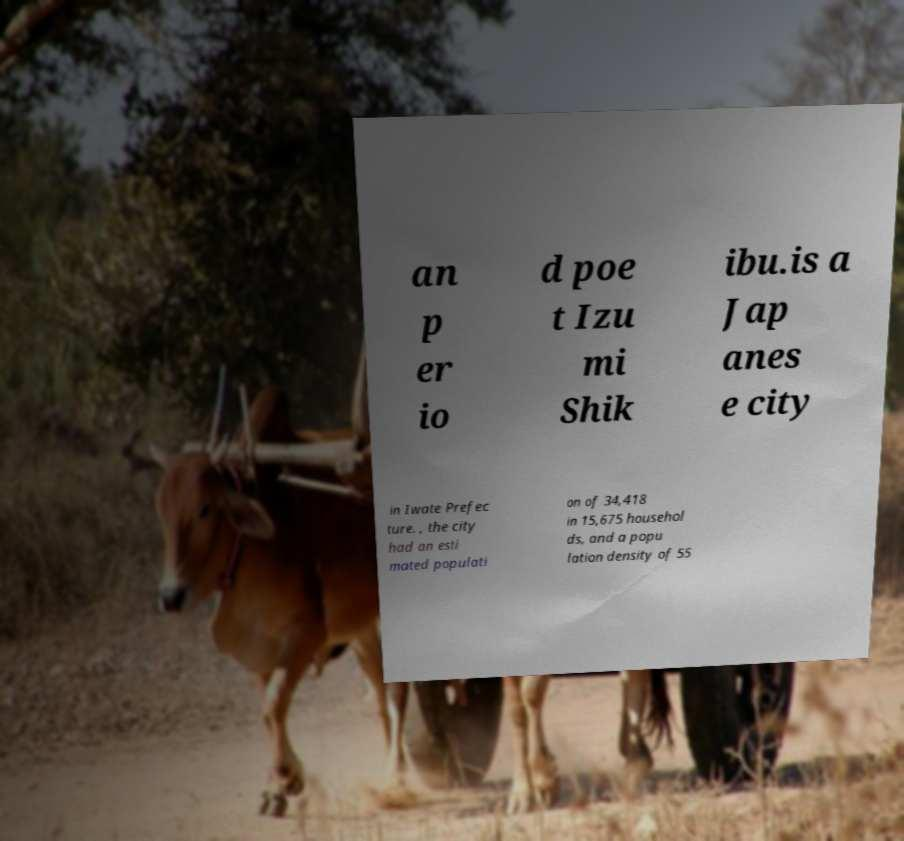For documentation purposes, I need the text within this image transcribed. Could you provide that? an p er io d poe t Izu mi Shik ibu.is a Jap anes e city in Iwate Prefec ture. , the city had an esti mated populati on of 34,418 in 15,675 househol ds, and a popu lation density of 55 